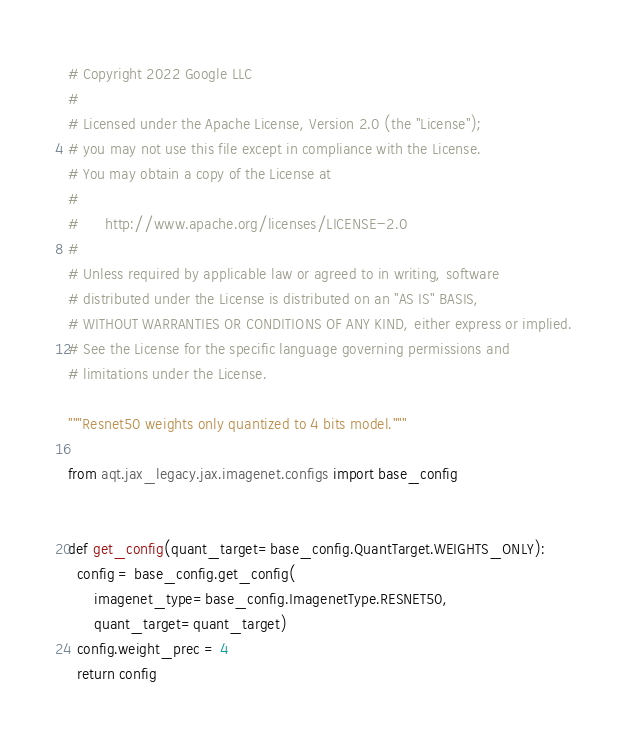<code> <loc_0><loc_0><loc_500><loc_500><_Python_># Copyright 2022 Google LLC
#
# Licensed under the Apache License, Version 2.0 (the "License");
# you may not use this file except in compliance with the License.
# You may obtain a copy of the License at
#
#      http://www.apache.org/licenses/LICENSE-2.0
#
# Unless required by applicable law or agreed to in writing, software
# distributed under the License is distributed on an "AS IS" BASIS,
# WITHOUT WARRANTIES OR CONDITIONS OF ANY KIND, either express or implied.
# See the License for the specific language governing permissions and
# limitations under the License.

"""Resnet50 weights only quantized to 4 bits model."""

from aqt.jax_legacy.jax.imagenet.configs import base_config


def get_config(quant_target=base_config.QuantTarget.WEIGHTS_ONLY):
  config = base_config.get_config(
      imagenet_type=base_config.ImagenetType.RESNET50,
      quant_target=quant_target)
  config.weight_prec = 4
  return config
</code> 